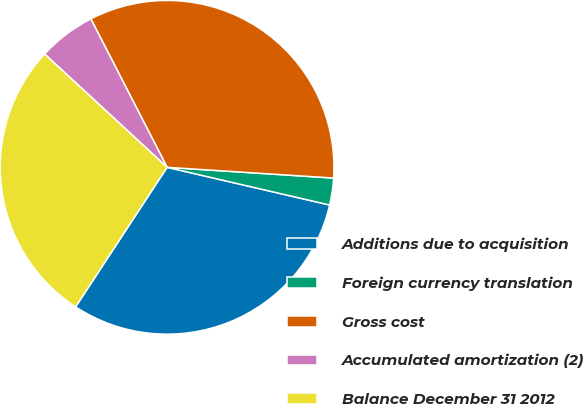Convert chart to OTSL. <chart><loc_0><loc_0><loc_500><loc_500><pie_chart><fcel>Additions due to acquisition<fcel>Foreign currency translation<fcel>Gross cost<fcel>Accumulated amortization (2)<fcel>Balance December 31 2012<nl><fcel>30.61%<fcel>2.6%<fcel>33.58%<fcel>5.57%<fcel>27.64%<nl></chart> 